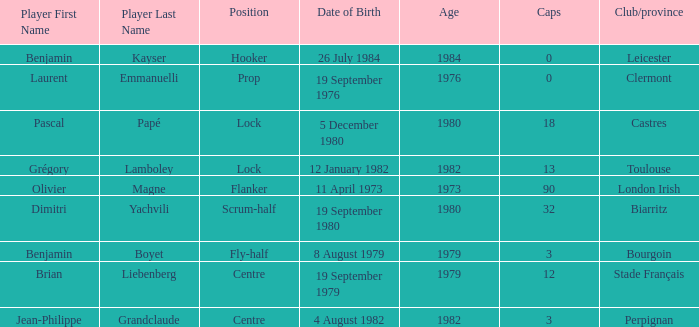Which player has a cap larger than 12 and Clubs of Toulouse? Grégory Lamboley. 